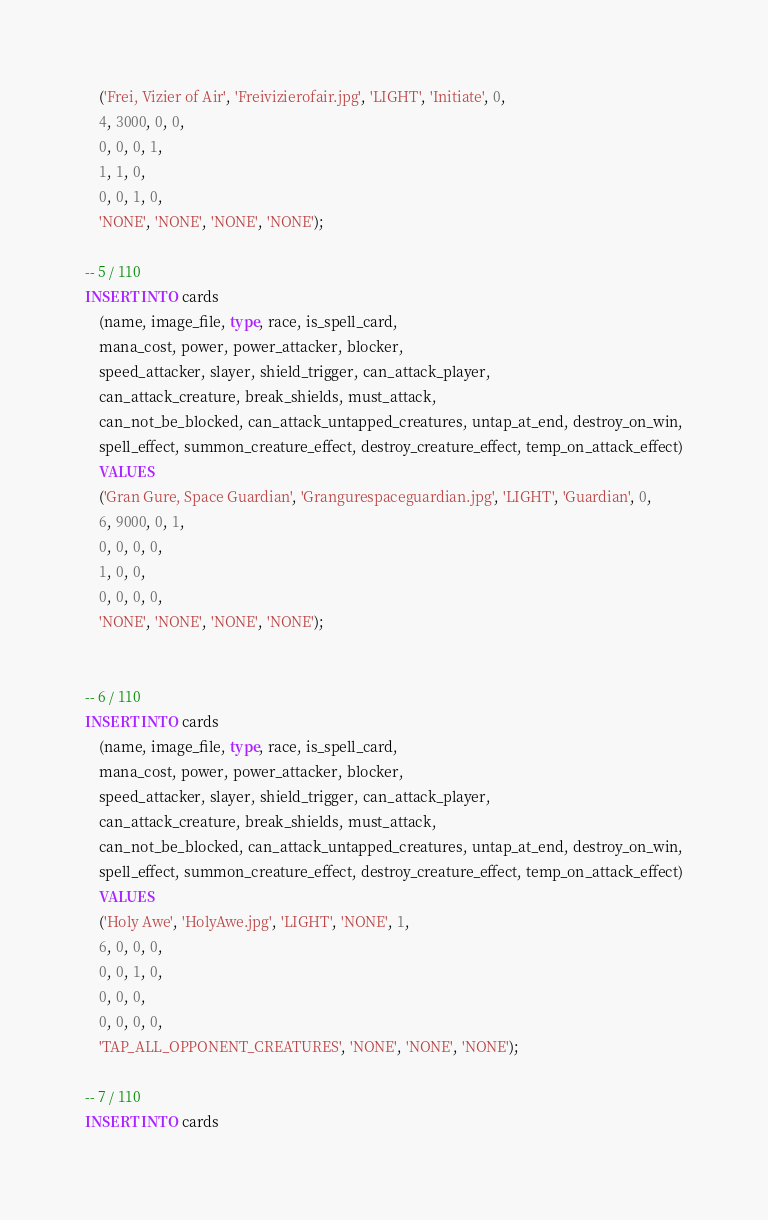<code> <loc_0><loc_0><loc_500><loc_500><_SQL_>    ('Frei, Vizier of Air', 'Freivizierofair.jpg', 'LIGHT', 'Initiate', 0,
    4, 3000, 0, 0,
    0, 0, 0, 1,
    1, 1, 0,
    0, 0, 1, 0,
    'NONE', 'NONE', 'NONE', 'NONE');

-- 5 / 110
INSERT INTO cards
    (name, image_file, type, race, is_spell_card,
    mana_cost, power, power_attacker, blocker,
    speed_attacker, slayer, shield_trigger, can_attack_player,
    can_attack_creature, break_shields, must_attack,
    can_not_be_blocked, can_attack_untapped_creatures, untap_at_end, destroy_on_win,
    spell_effect, summon_creature_effect, destroy_creature_effect, temp_on_attack_effect)
    VALUES
    ('Gran Gure, Space Guardian', 'Grangurespaceguardian.jpg', 'LIGHT', 'Guardian', 0,
    6, 9000, 0, 1,
    0, 0, 0, 0,
    1, 0, 0,
    0, 0, 0, 0,
    'NONE', 'NONE', 'NONE', 'NONE');


-- 6 / 110
INSERT INTO cards
    (name, image_file, type, race, is_spell_card,
    mana_cost, power, power_attacker, blocker,
    speed_attacker, slayer, shield_trigger, can_attack_player,
    can_attack_creature, break_shields, must_attack,
    can_not_be_blocked, can_attack_untapped_creatures, untap_at_end, destroy_on_win,
    spell_effect, summon_creature_effect, destroy_creature_effect, temp_on_attack_effect)
    VALUES
    ('Holy Awe', 'HolyAwe.jpg', 'LIGHT', 'NONE', 1,
    6, 0, 0, 0,
    0, 0, 1, 0,
    0, 0, 0,
    0, 0, 0, 0,
    'TAP_ALL_OPPONENT_CREATURES', 'NONE', 'NONE', 'NONE');

-- 7 / 110
INSERT INTO cards</code> 